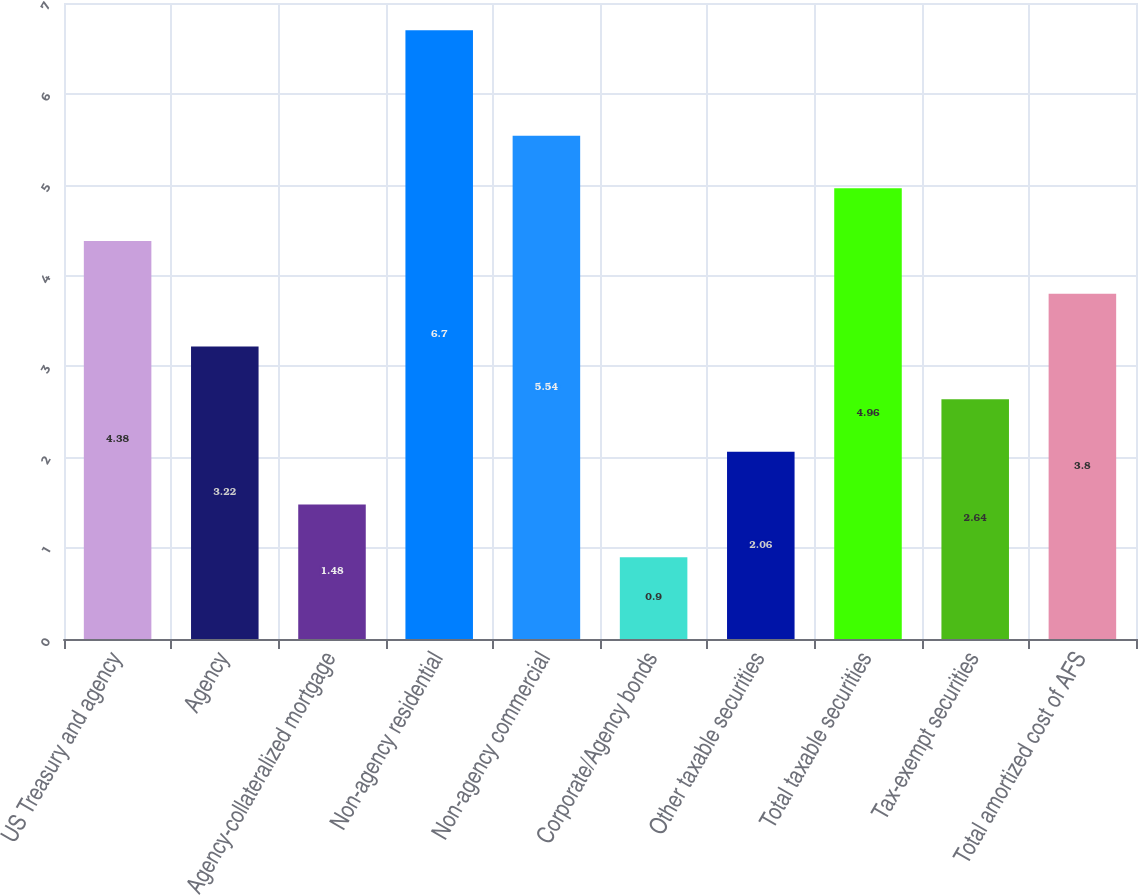<chart> <loc_0><loc_0><loc_500><loc_500><bar_chart><fcel>US Treasury and agency<fcel>Agency<fcel>Agency-collateralized mortgage<fcel>Non-agency residential<fcel>Non-agency commercial<fcel>Corporate/Agency bonds<fcel>Other taxable securities<fcel>Total taxable securities<fcel>Tax-exempt securities<fcel>Total amortized cost of AFS<nl><fcel>4.38<fcel>3.22<fcel>1.48<fcel>6.7<fcel>5.54<fcel>0.9<fcel>2.06<fcel>4.96<fcel>2.64<fcel>3.8<nl></chart> 